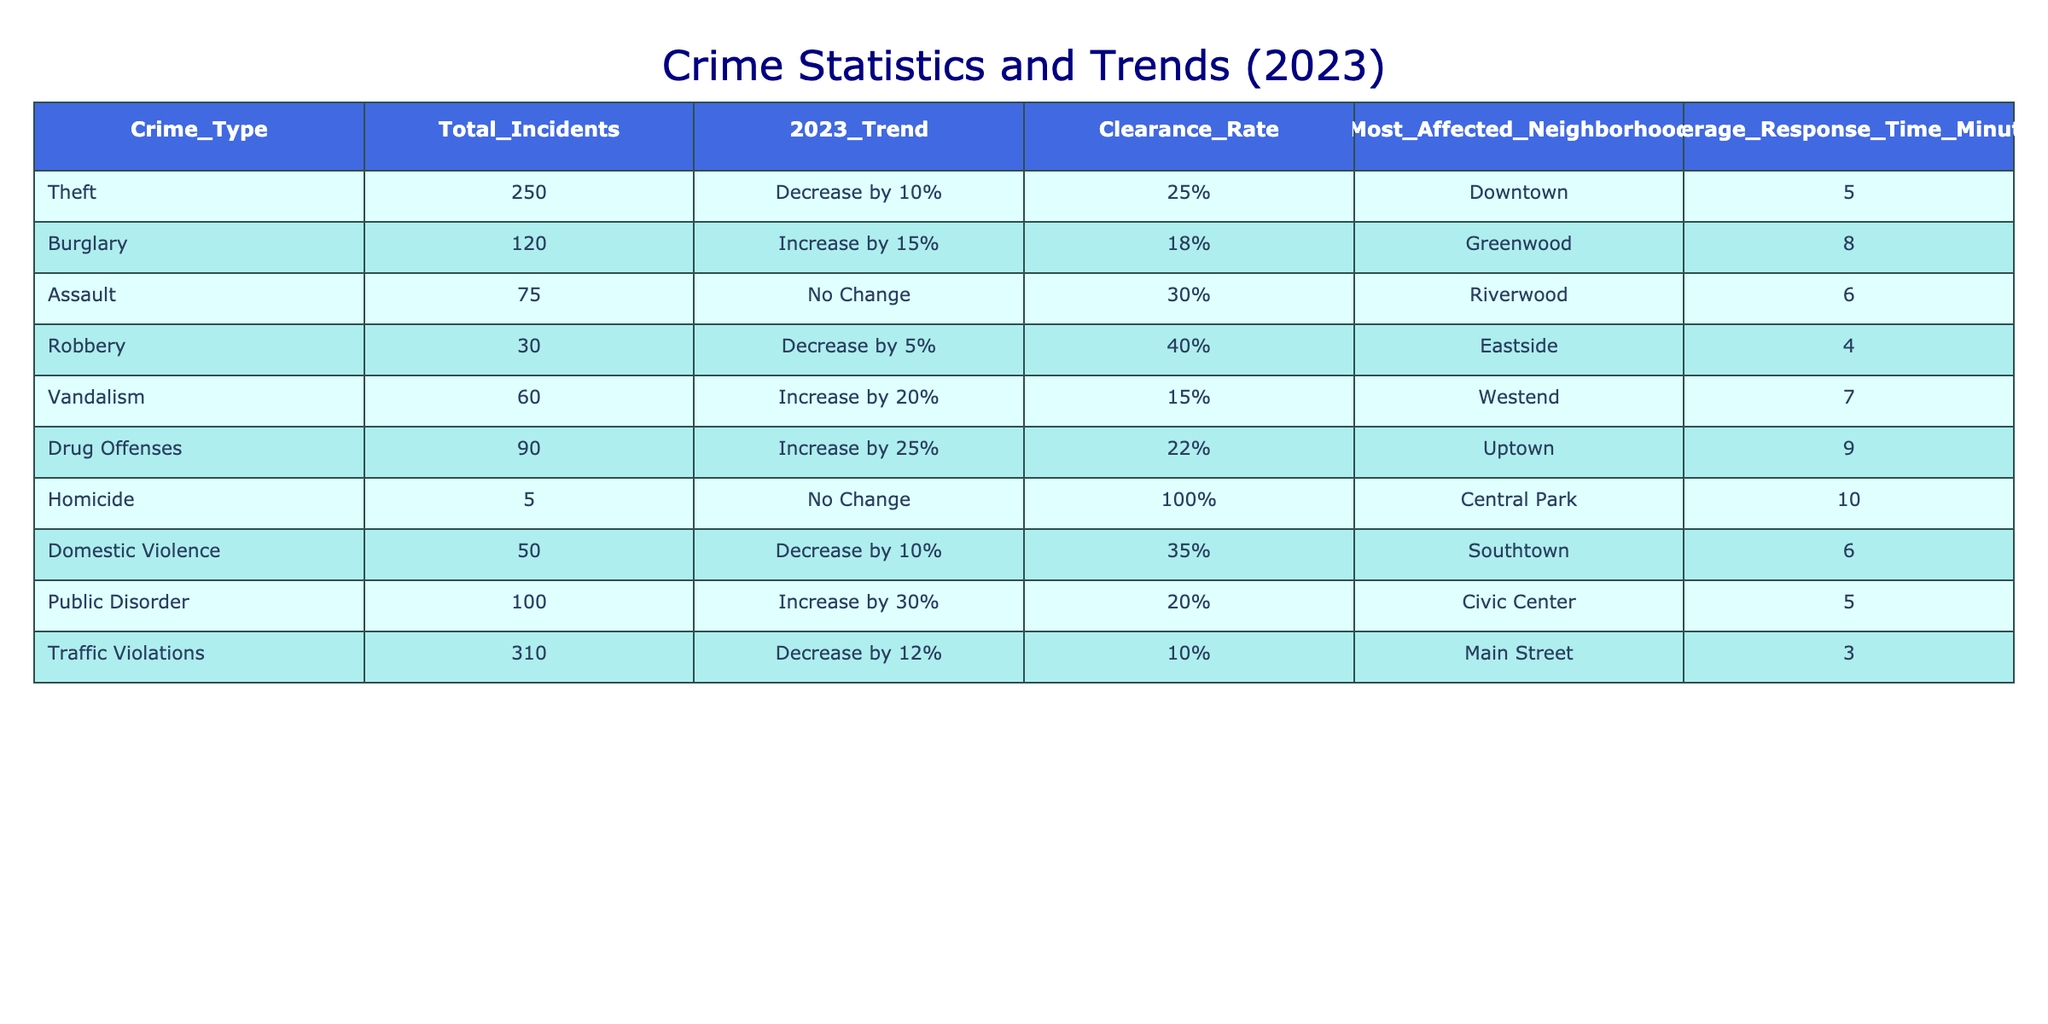What is the total number of theft incidents reported in 2023? The table shows that the crime type "Theft" has a total of 250 incidents reported in 2023. This value is directly found in the column for Total Incidents corresponding to Theft.
Answer: 250 Which neighborhood has the highest clearance rate for crimes in the table? To find the highest clearance rate, compare the clearance rates of all neighborhoods. The clearance rates are as follows: Downtown (25%), Greenwood (18%), Riverwood (30%), Eastside (40%), Westend (15%), Uptown (22%), Central Park (100%), Southtown (35%), Civic Center (20%), and Main Street (10%). The highest rate is 100% in Central Park.
Answer: Central Park How many total incidents of drug offenses and burglary were reported in 2023? The total incidents for drug offenses is 90 and for burglary is 120. Adding these together gives: 90 + 120 = 210.
Answer: 210 Is the total number of traffic violations higher than the total number of theft incidents? The table indicates that there are 310 traffic violations and 250 theft incidents. Since 310 is greater than 250, the answer is yes.
Answer: Yes What is the average response time for the crime type with the most incidents? The crime type with the most incidents is traffic violations with 310 incidents, and its average response time is 3 minutes. Thus, the average response time for the crime type with the most incidents is 3.
Answer: 3 minutes How many total incidents decreased compared to the previous year (combining theft and domestic violence)? The theft incidents decreased by 10%, and domestic violence decreased by 10%. The number of theft incidents (250) decreases by 10% giving 25 incidents, while domestic violence (50) decreases by 10% giving 5 incidents. Therefore, the total decrease is 25 + 5 = 30.
Answer: 30 In which neighborhood did the highest number of drug offenses occur? The table indicates that the most affected neighborhood for drug offenses is Uptown, where 90 incidents were reported. This information is specified in the Most Affected Neighborhood column corresponding to Drug Offenses.
Answer: Uptown What is the difference in the number of incidents between public disorder and robbery? The number of public disorder incidents is 100, while robbery incidents total 30. To find the difference: 100 - 30 = 70.
Answer: 70 Which type of crime had no change in incidents compared to last year? The table shows that both Assault and Homicide reported no change in incidents compared to the previous year, as indicated in the 2023 Trend column.
Answer: Assault and Homicide 